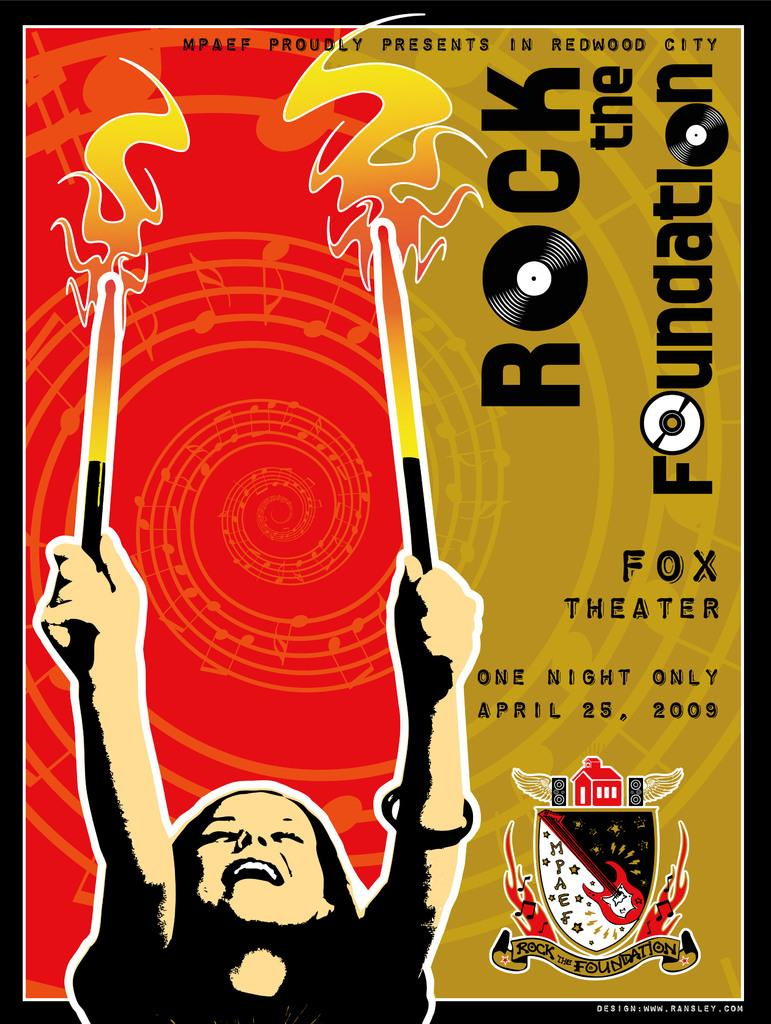<image>
Write a terse but informative summary of the picture. A poster for an event called "Rock the Foundation" features a woman holding up two drumsticks. 